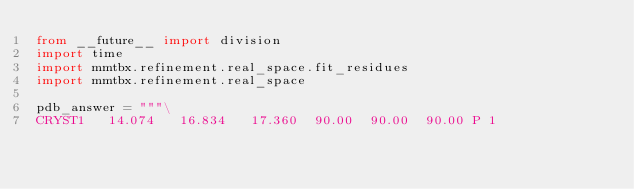<code> <loc_0><loc_0><loc_500><loc_500><_Python_>from __future__ import division
import time
import mmtbx.refinement.real_space.fit_residues
import mmtbx.refinement.real_space

pdb_answer = """\
CRYST1   14.074   16.834   17.360  90.00  90.00  90.00 P 1</code> 